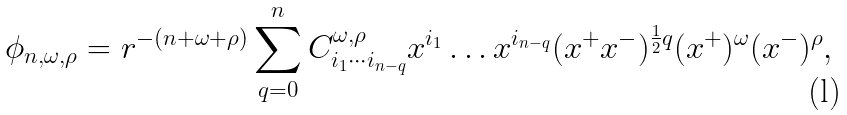Convert formula to latex. <formula><loc_0><loc_0><loc_500><loc_500>\phi _ { n , \omega , \rho } = r ^ { - ( n + \omega + \rho ) } \sum _ { q = 0 } ^ { n } C ^ { \omega , \rho } _ { i _ { 1 } \cdots i _ { n - q } } x ^ { i _ { 1 } } \dots x ^ { i _ { n - q } } ( x ^ { + } x ^ { - } ) ^ { \frac { 1 } { 2 } q } ( x ^ { + } ) ^ { \omega } ( x ^ { - } ) ^ { \rho } ,</formula> 